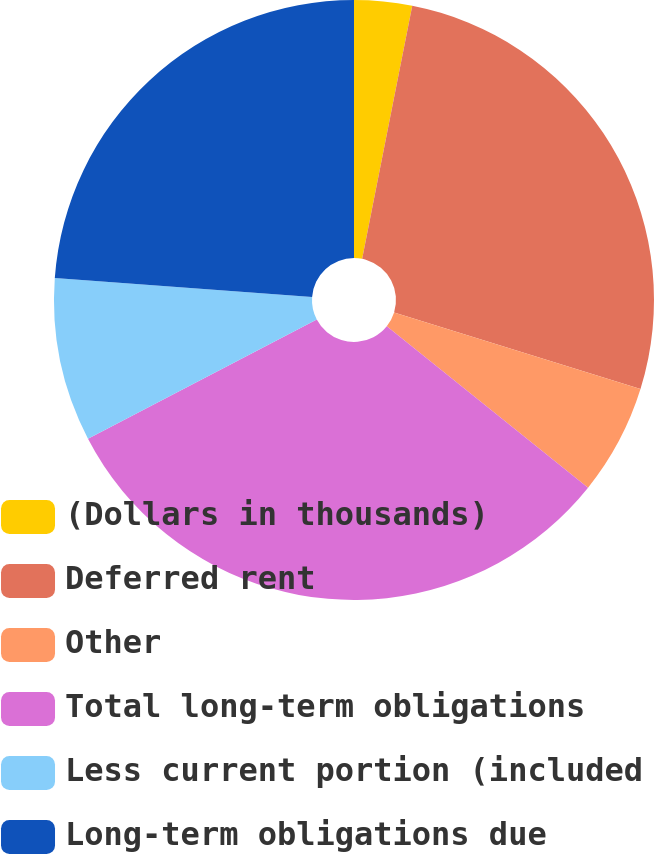<chart> <loc_0><loc_0><loc_500><loc_500><pie_chart><fcel>(Dollars in thousands)<fcel>Deferred rent<fcel>Other<fcel>Total long-term obligations<fcel>Less current portion (included<fcel>Long-term obligations due<nl><fcel>3.11%<fcel>26.69%<fcel>5.96%<fcel>31.6%<fcel>8.81%<fcel>23.84%<nl></chart> 